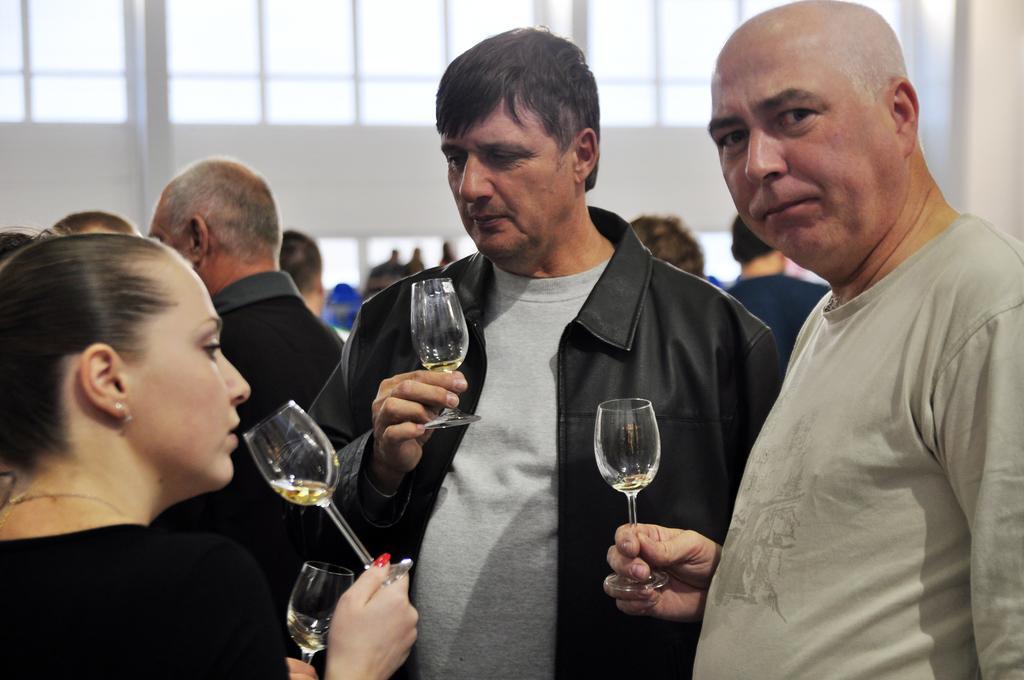Describe this image in one or two sentences. This is the picture of group of people standing and holding the glass of wine in their hands and in back ground there is a building and some group of people standing. 